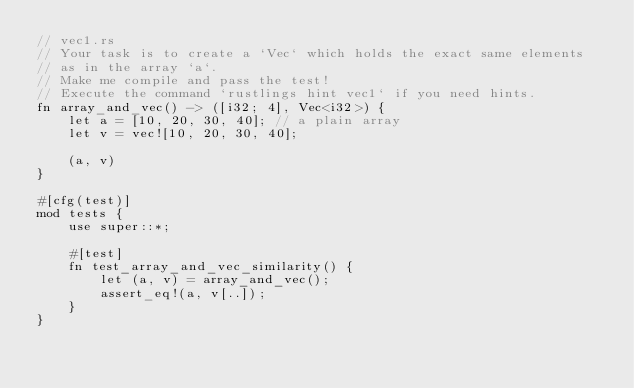<code> <loc_0><loc_0><loc_500><loc_500><_Rust_>// vec1.rs
// Your task is to create a `Vec` which holds the exact same elements
// as in the array `a`.
// Make me compile and pass the test!
// Execute the command `rustlings hint vec1` if you need hints.
fn array_and_vec() -> ([i32; 4], Vec<i32>) {
    let a = [10, 20, 30, 40]; // a plain array
    let v = vec![10, 20, 30, 40];

    (a, v)
}

#[cfg(test)]
mod tests {
    use super::*;

    #[test]
    fn test_array_and_vec_similarity() {
        let (a, v) = array_and_vec();
        assert_eq!(a, v[..]);
    }
}
</code> 